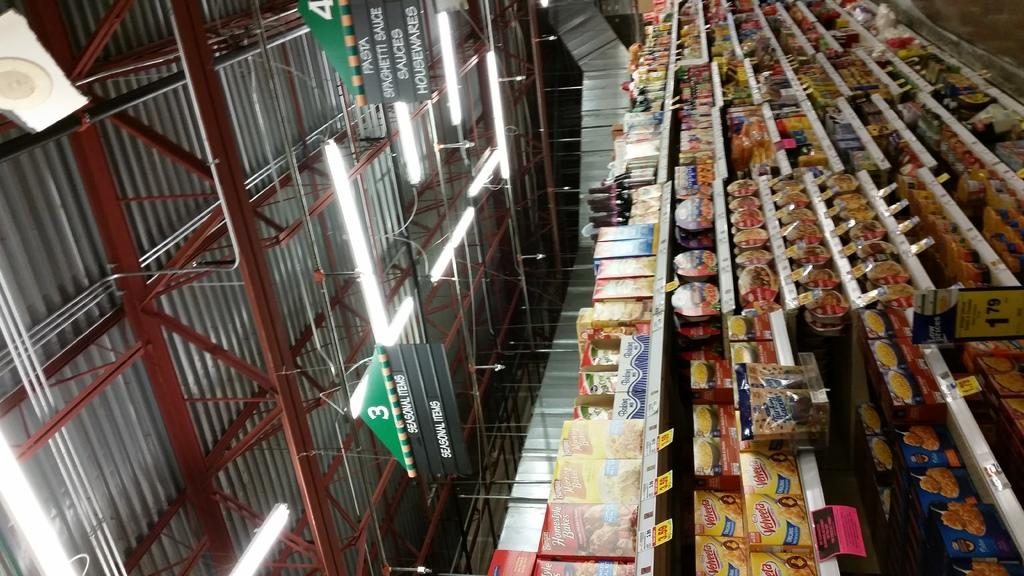<image>
Render a clear and concise summary of the photo. the inside of a store with a green sign on the top of it that says 3 